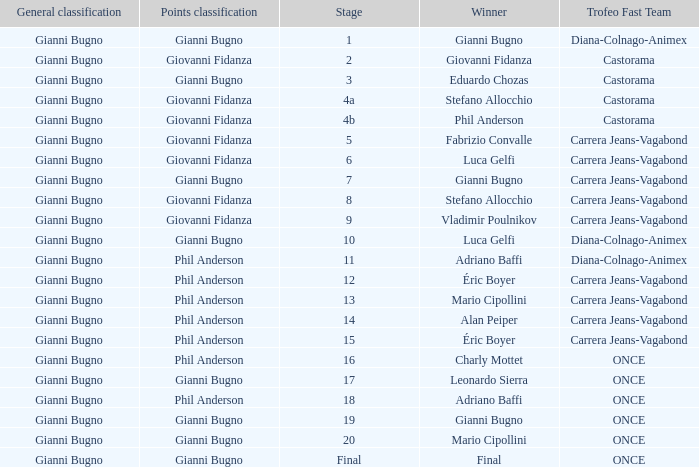Who is the trofeo fast team in stage 10? Diana-Colnago-Animex. 